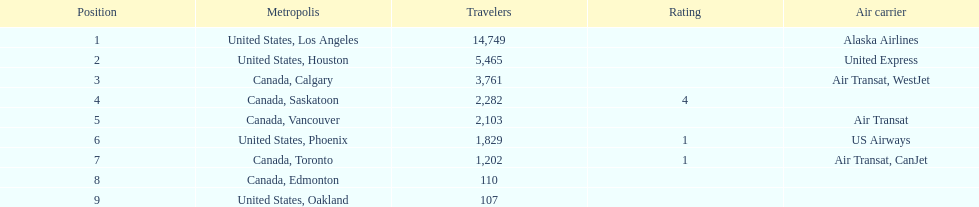Los angeles and what other city had about 19,000 passenger combined Canada, Calgary. 